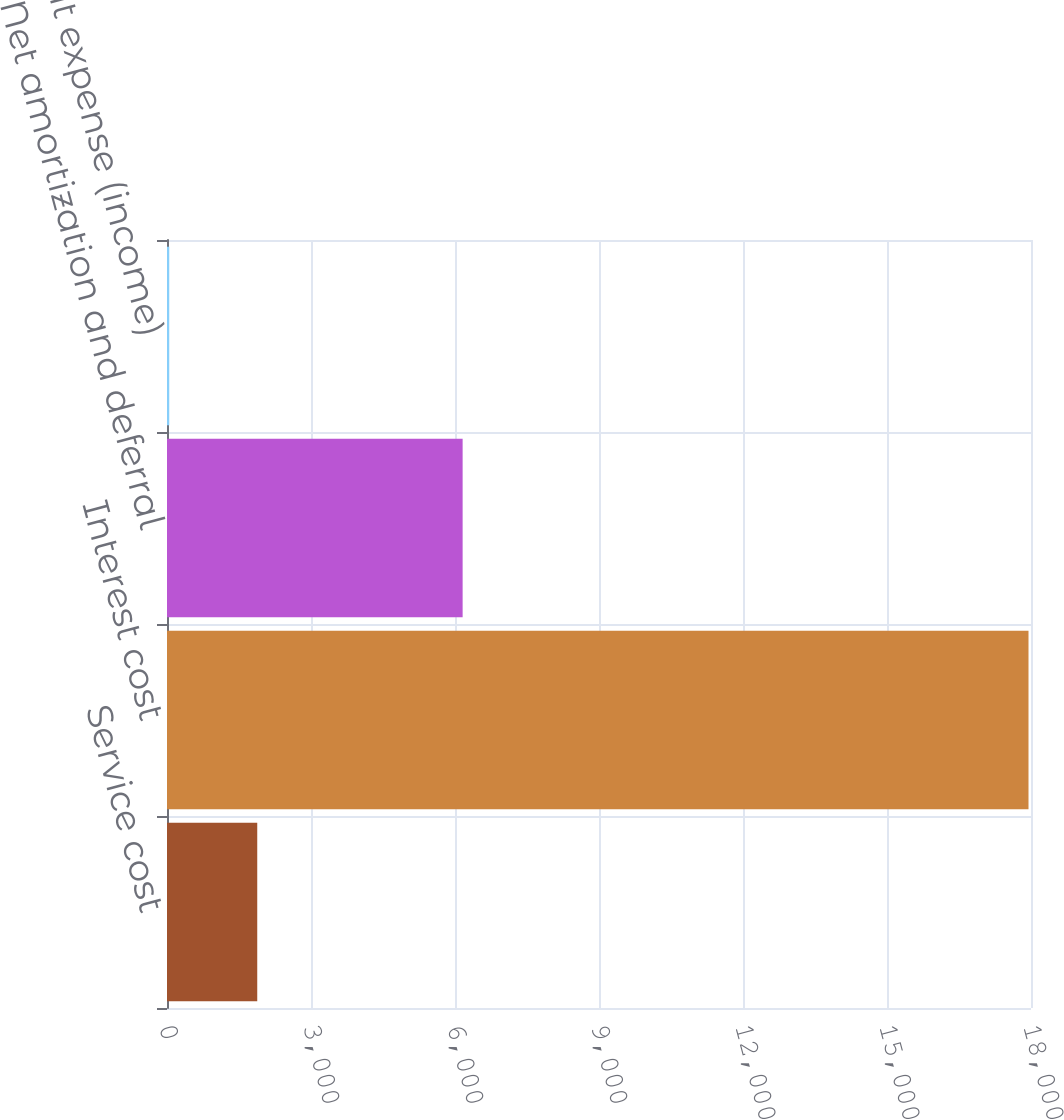Convert chart to OTSL. <chart><loc_0><loc_0><loc_500><loc_500><bar_chart><fcel>Service cost<fcel>Interest cost<fcel>Net amortization and deferral<fcel>Net benefit expense (income)<nl><fcel>1880<fcel>17948<fcel>6159<fcel>47<nl></chart> 